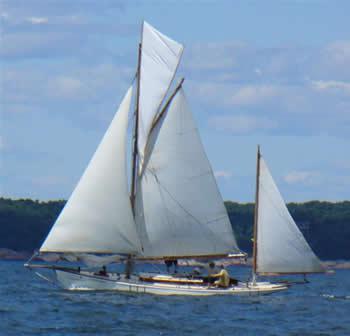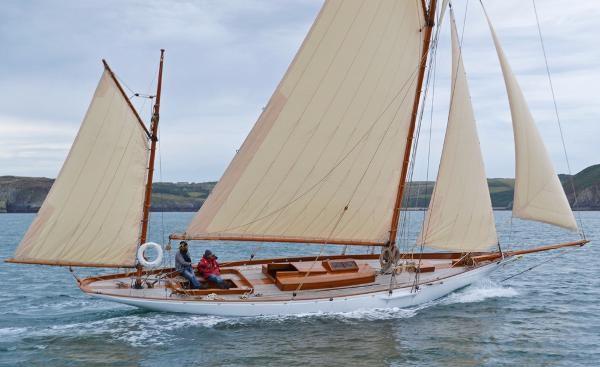The first image is the image on the left, the second image is the image on the right. Considering the images on both sides, is "the sailboat has no more than 3 sails" valid? Answer yes or no. No. The first image is the image on the left, the second image is the image on the right. For the images displayed, is the sentence "One boat has more than 3 sails" factually correct? Answer yes or no. Yes. 